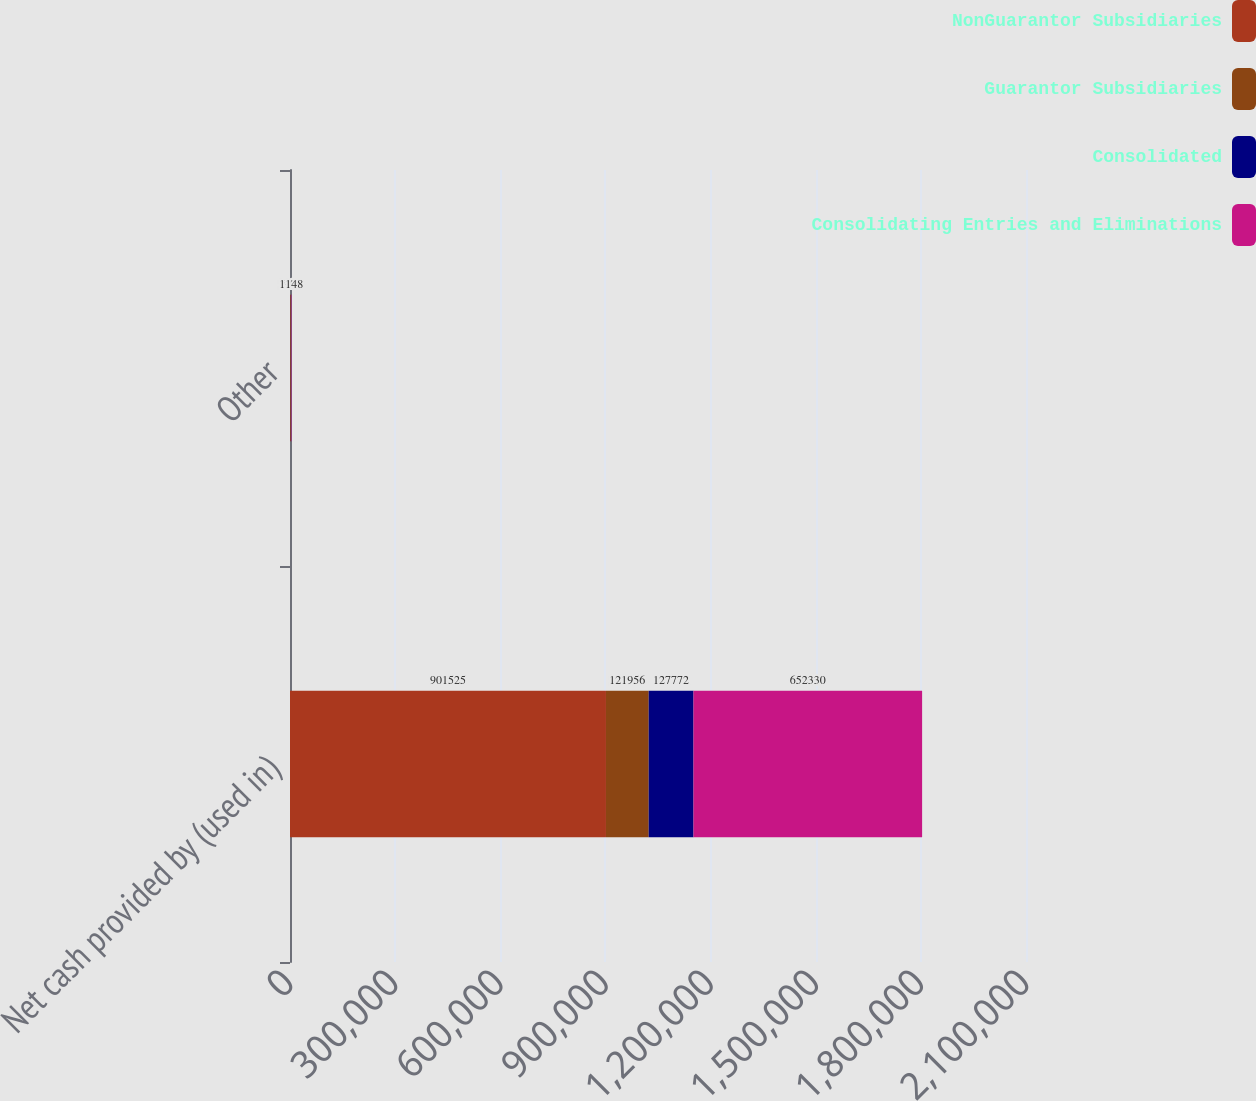Convert chart to OTSL. <chart><loc_0><loc_0><loc_500><loc_500><stacked_bar_chart><ecel><fcel>Net cash provided by (used in)<fcel>Other<nl><fcel>NonGuarantor Subsidiaries<fcel>901525<fcel>1962<nl><fcel>Guarantor Subsidiaries<fcel>121956<fcel>566<nl><fcel>Consolidated<fcel>127772<fcel>541<nl><fcel>Consolidating Entries and Eliminations<fcel>652330<fcel>1148<nl></chart> 